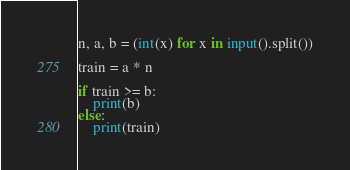Convert code to text. <code><loc_0><loc_0><loc_500><loc_500><_Python_>n, a, b = (int(x) for x in input().split())

train = a * n

if train >= b:
    print(b)
else:
    print(train)
</code> 